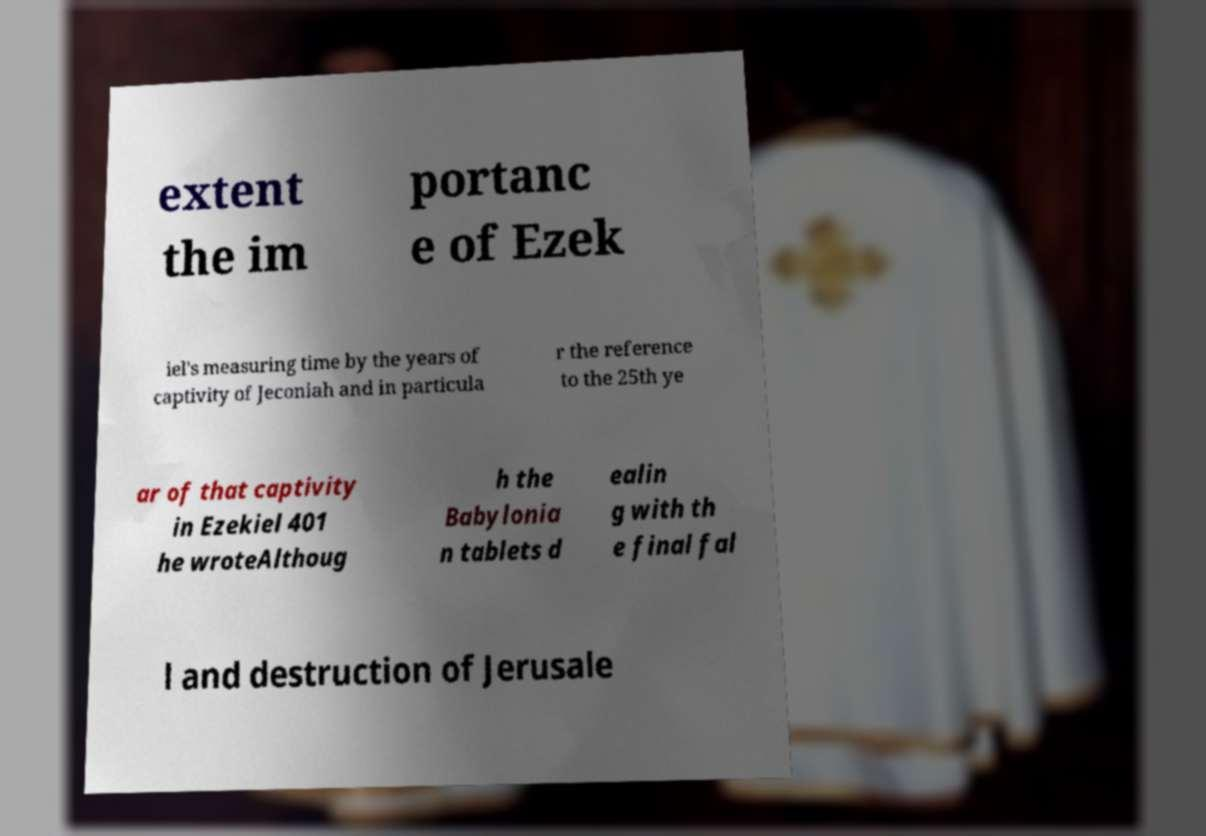What messages or text are displayed in this image? I need them in a readable, typed format. extent the im portanc e of Ezek iel's measuring time by the years of captivity of Jeconiah and in particula r the reference to the 25th ye ar of that captivity in Ezekiel 401 he wroteAlthoug h the Babylonia n tablets d ealin g with th e final fal l and destruction of Jerusale 